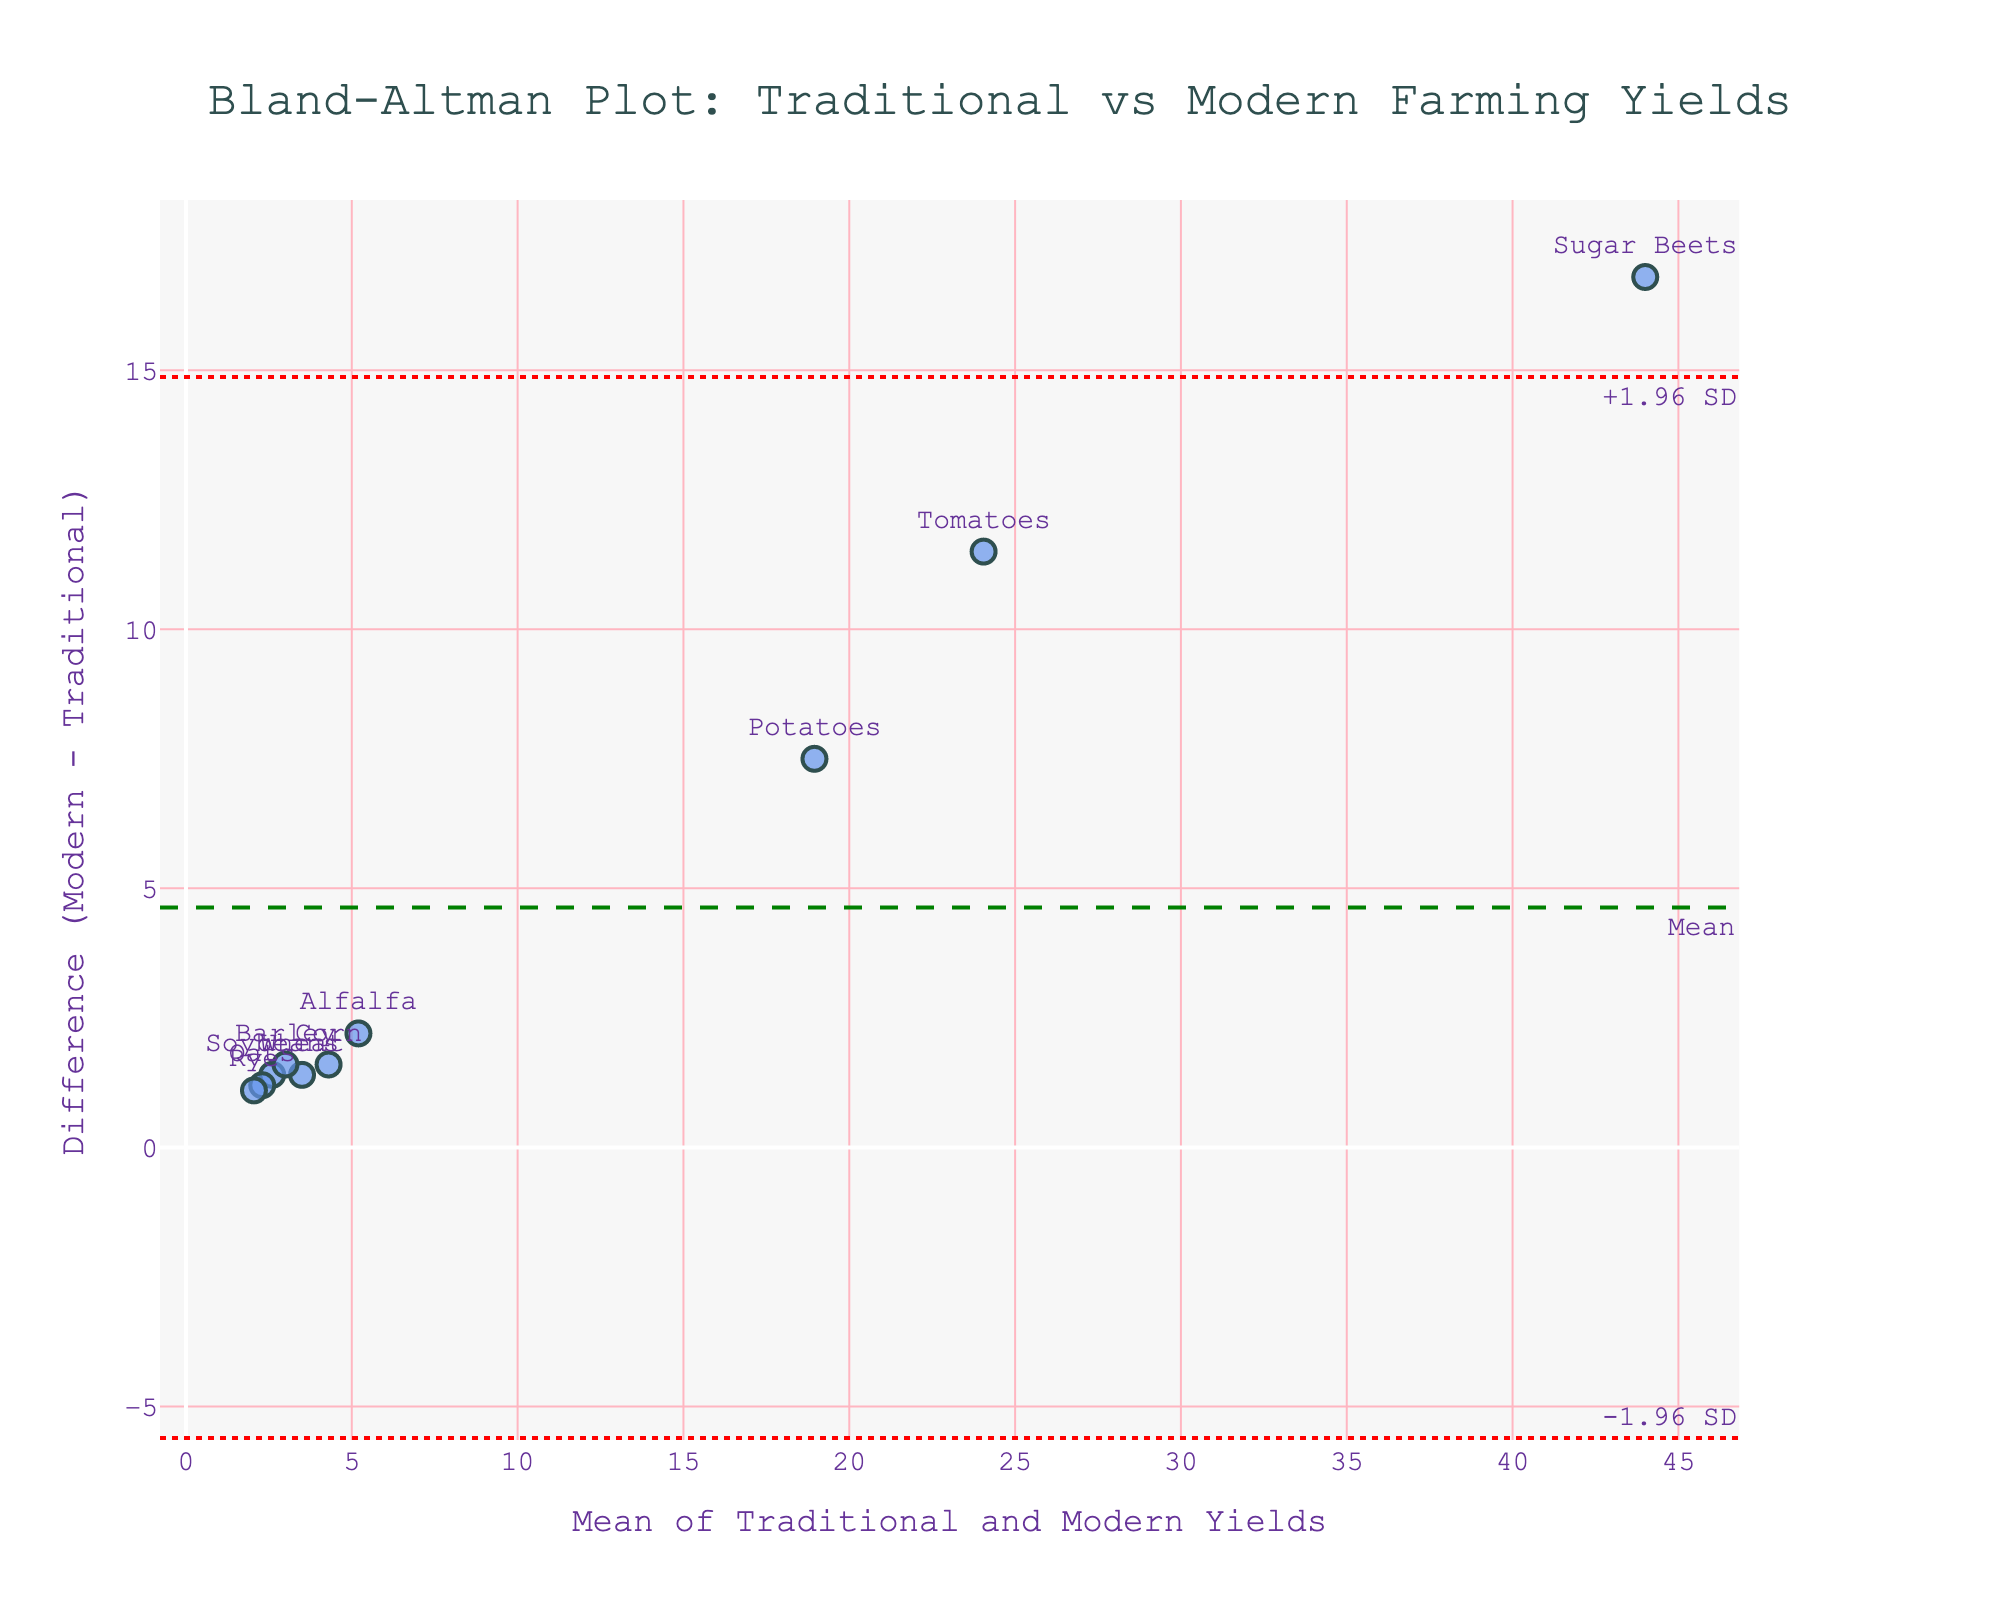What is the title of the plot? The title is displayed at the top of the plot.
Answer: Bland-Altman Plot: Traditional vs Modern Farming Yields How many crop data points are represented in the plot? Each marker on the plot represents a crop. Counting them gives the total number.
Answer: 10 Which crop has the highest yield difference between traditional and modern farming methods? The yield difference is shown on the y-axis, and the label next to the highest point gives the crop name.
Answer: Sugar Beets What is the mean difference between traditional and modern crop yields? The mean difference is the green dashed line labeled "Mean".
Answer: (numeric value from the plot) What are the upper and lower limits of agreement, and how are they visualized? The upper and lower limits are shown as red dotted lines on the plot, labeled "+1.96 SD" and "-1.96 SD".
Answer: (numeric values from the plot) Which crop's yield difference is closest to the mean difference? The crop marker closest to the green dashed mean line indicates this information.
Answer: (crop label from the plot) Are there any crops where modern yields are lower than traditional yields? Check if any points lie below the zero line on the y-axis.
Answer: No Which crop has the largest average yield (mean of traditional and modern yields)? The crop with the highest x-axis value represents the largest average yield.
Answer: Sugar Beets Between which two crops is the difference in yield differences the smallest? Locate two points on the plot that are closest together vertically.
Answer: (two crop names from the plot) How can you tell from the plot if there's a systematic bias in modern agricultural techniques compared to traditional methods? A systematic bias would show if most points are consistently above or below the zero difference line. Checking this can confirm a bias.
Answer: There is a positive bias 